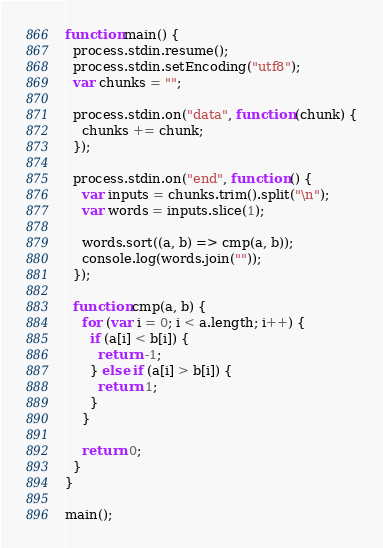<code> <loc_0><loc_0><loc_500><loc_500><_JavaScript_>function main() {
  process.stdin.resume();
  process.stdin.setEncoding("utf8");
  var chunks = "";

  process.stdin.on("data", function (chunk) {
    chunks += chunk;
  });

  process.stdin.on("end", function () {
    var inputs = chunks.trim().split("\n");
    var words = inputs.slice(1);

    words.sort((a, b) => cmp(a, b));
    console.log(words.join(""));
  });

  function cmp(a, b) {
    for (var i = 0; i < a.length; i++) {
      if (a[i] < b[i]) {
        return -1;
      } else if (a[i] > b[i]) {
        return 1;
      }
    }

    return 0;
  }
}

main();
</code> 